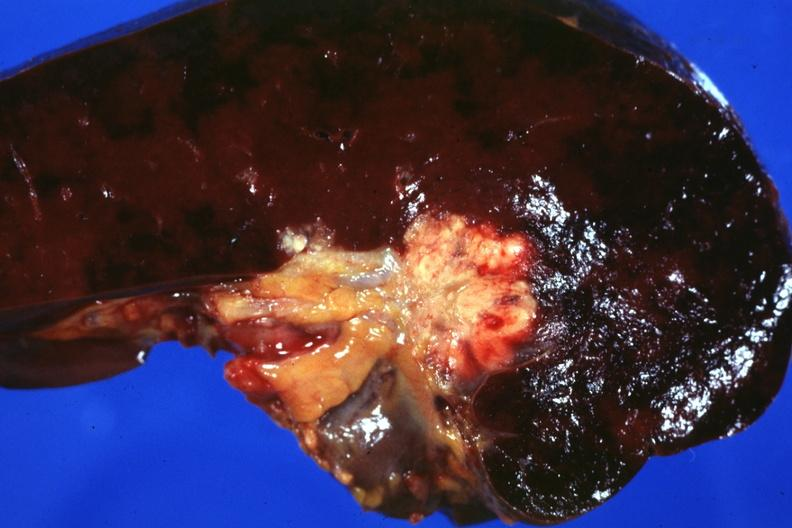does acid show section of spleen through hilum show tumor mass in hilum slide and large metastatic nodules in spleen?
Answer the question using a single word or phrase. No 